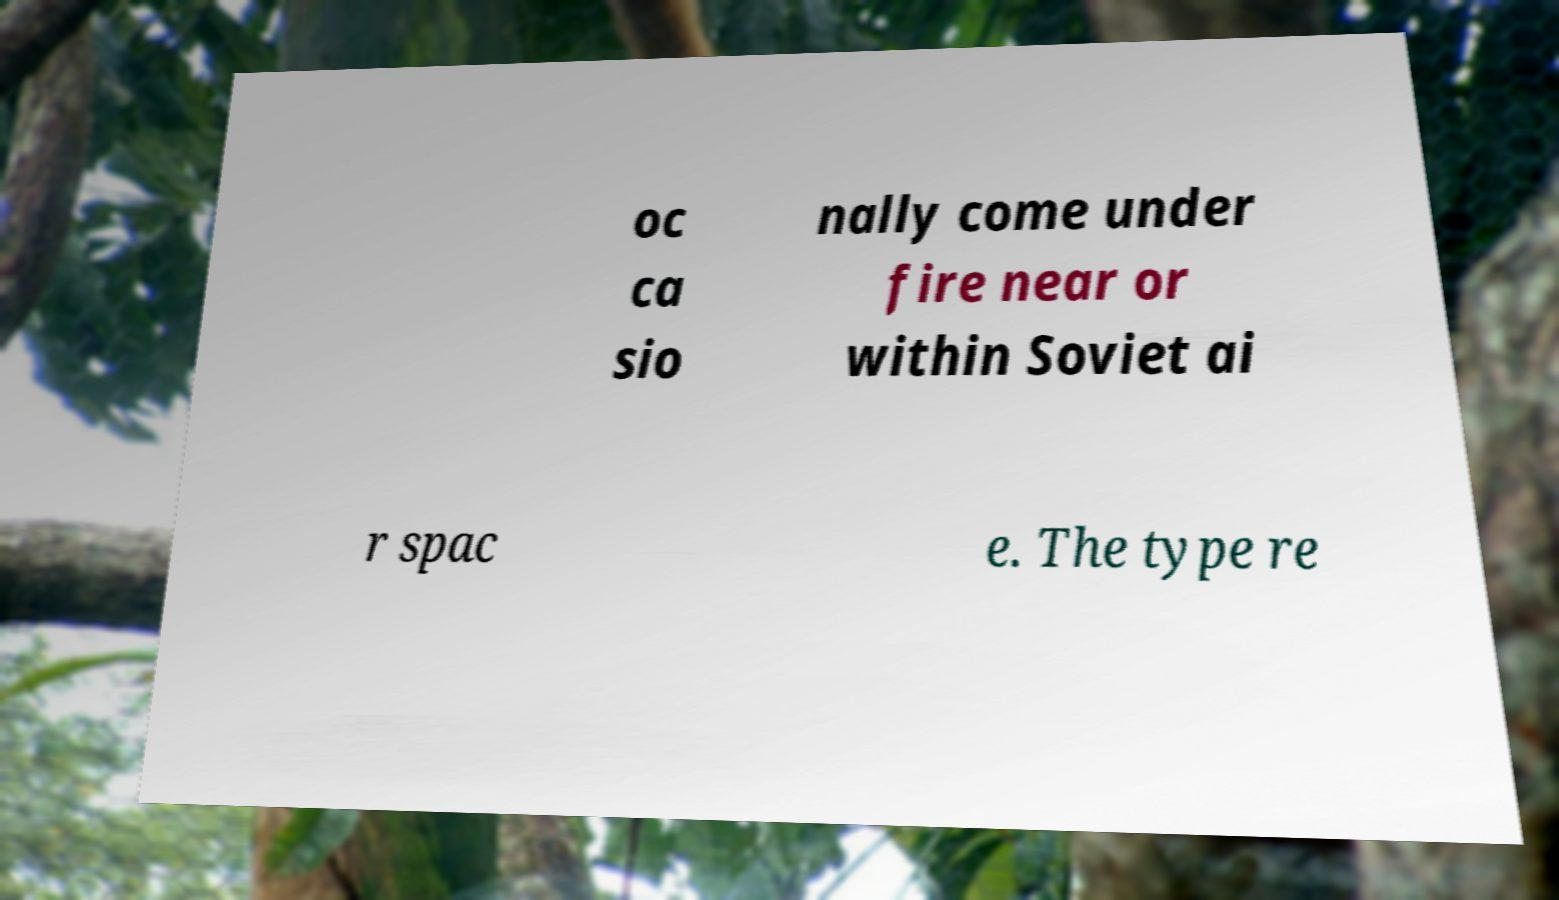I need the written content from this picture converted into text. Can you do that? oc ca sio nally come under fire near or within Soviet ai r spac e. The type re 